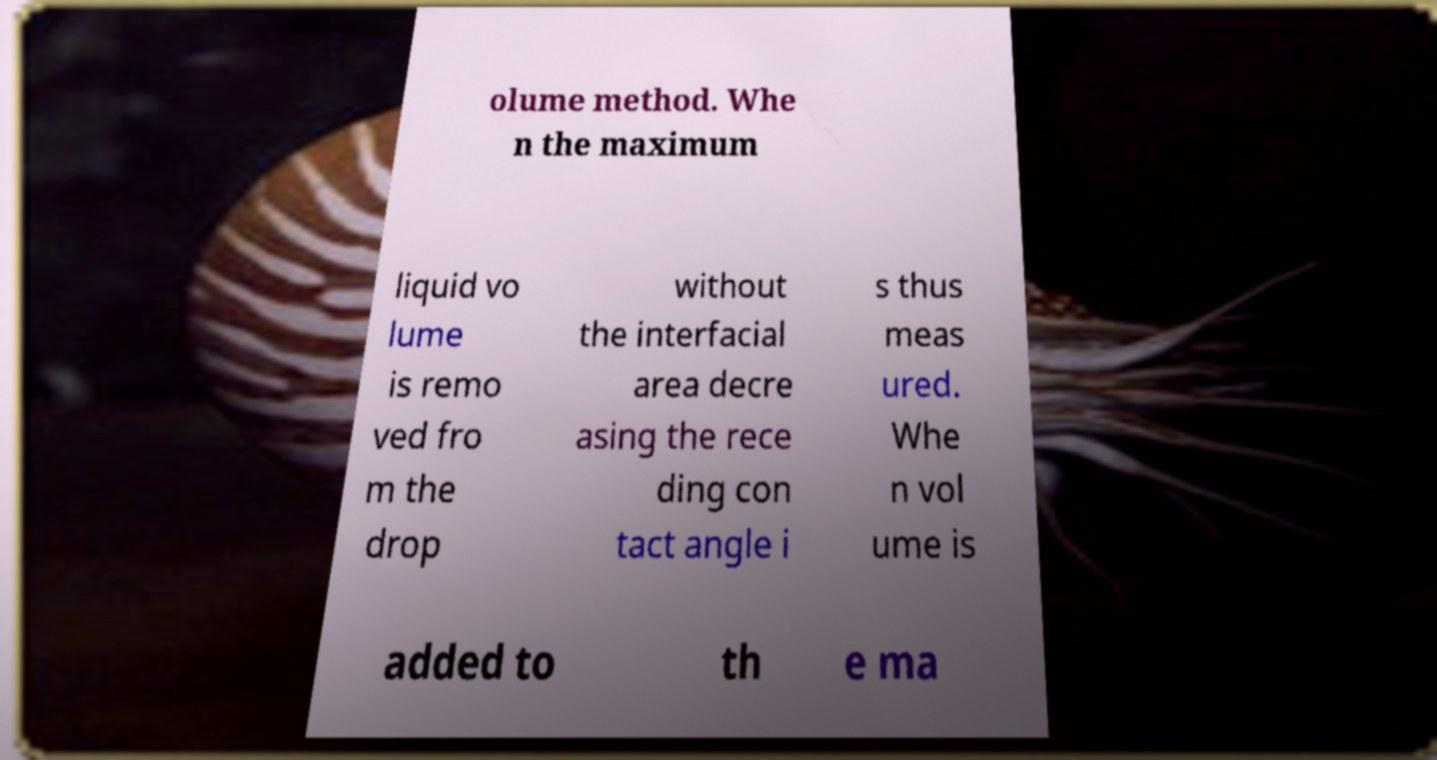Please read and relay the text visible in this image. What does it say? olume method. Whe n the maximum liquid vo lume is remo ved fro m the drop without the interfacial area decre asing the rece ding con tact angle i s thus meas ured. Whe n vol ume is added to th e ma 